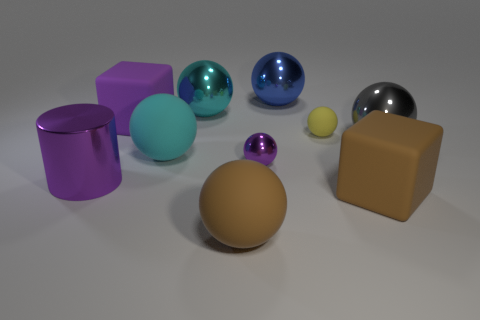Is the tiny metallic sphere the same color as the shiny cylinder?
Ensure brevity in your answer.  Yes. Are there any other things that are the same shape as the big purple metallic thing?
Ensure brevity in your answer.  No. Is the number of brown matte balls that are in front of the large brown matte sphere less than the number of big green cylinders?
Your response must be concise. No. What number of green metal things are there?
Ensure brevity in your answer.  0. How many objects have the same color as the cylinder?
Your answer should be very brief. 2. Is the shape of the gray metallic thing the same as the tiny rubber thing?
Provide a short and direct response. Yes. There is a brown thing on the right side of the big rubber ball in front of the purple ball; what is its size?
Give a very brief answer. Large. Is there a purple shiny thing that has the same size as the purple sphere?
Keep it short and to the point. No. Do the cyan sphere that is in front of the big gray metal thing and the purple metal thing right of the purple cylinder have the same size?
Your response must be concise. No. The big purple object to the right of the metallic thing that is in front of the tiny metal sphere is what shape?
Give a very brief answer. Cube. 